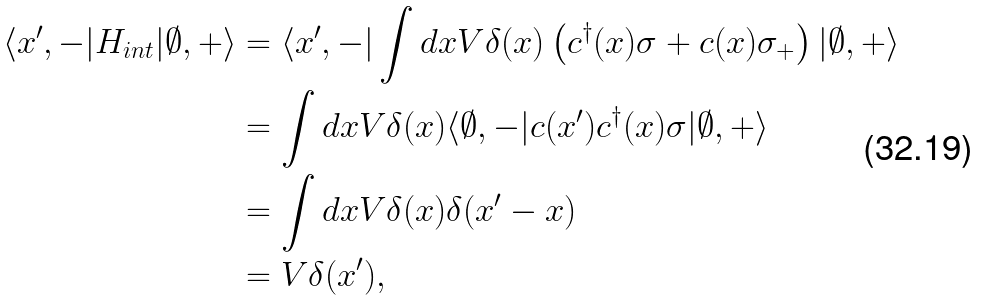<formula> <loc_0><loc_0><loc_500><loc_500>\langle x ^ { \prime } , - | H _ { i n t } | \emptyset , + \rangle & = \langle x ^ { \prime } , - | \int d x V \delta ( x ) \left ( c ^ { \dagger } ( x ) \sigma + c ( x ) \sigma _ { + } \right ) | \emptyset , + \rangle \\ & = \int d x V \delta ( x ) \langle \emptyset , - | c ( x ^ { \prime } ) c ^ { \dagger } ( x ) \sigma | \emptyset , + \rangle \\ & = \int d x V \delta ( x ) \delta ( x ^ { \prime } - x ) \\ & = V \delta ( x ^ { \prime } ) ,</formula> 